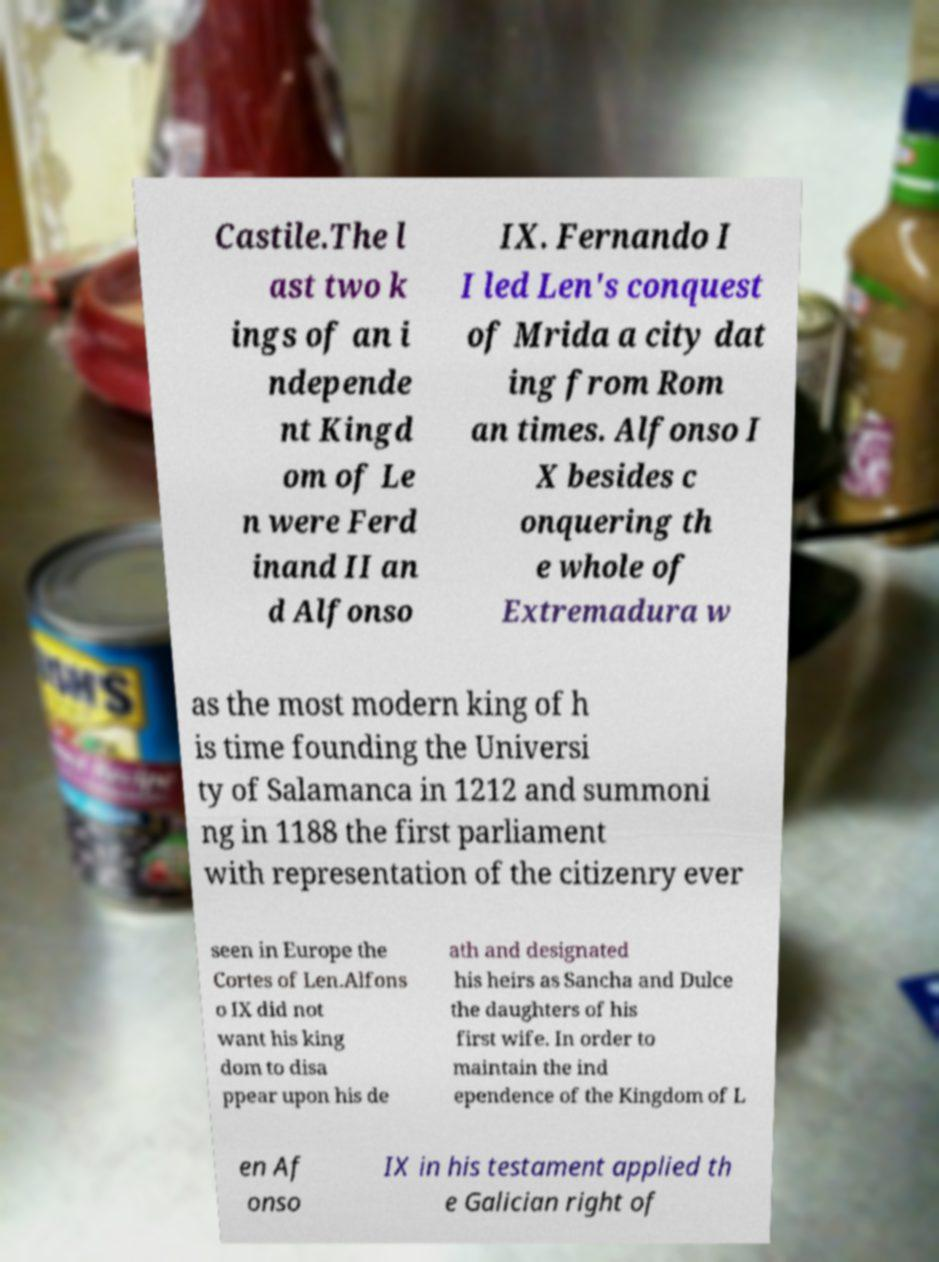Please identify and transcribe the text found in this image. Castile.The l ast two k ings of an i ndepende nt Kingd om of Le n were Ferd inand II an d Alfonso IX. Fernando I I led Len's conquest of Mrida a city dat ing from Rom an times. Alfonso I X besides c onquering th e whole of Extremadura w as the most modern king of h is time founding the Universi ty of Salamanca in 1212 and summoni ng in 1188 the first parliament with representation of the citizenry ever seen in Europe the Cortes of Len.Alfons o IX did not want his king dom to disa ppear upon his de ath and designated his heirs as Sancha and Dulce the daughters of his first wife. In order to maintain the ind ependence of the Kingdom of L en Af onso IX in his testament applied th e Galician right of 